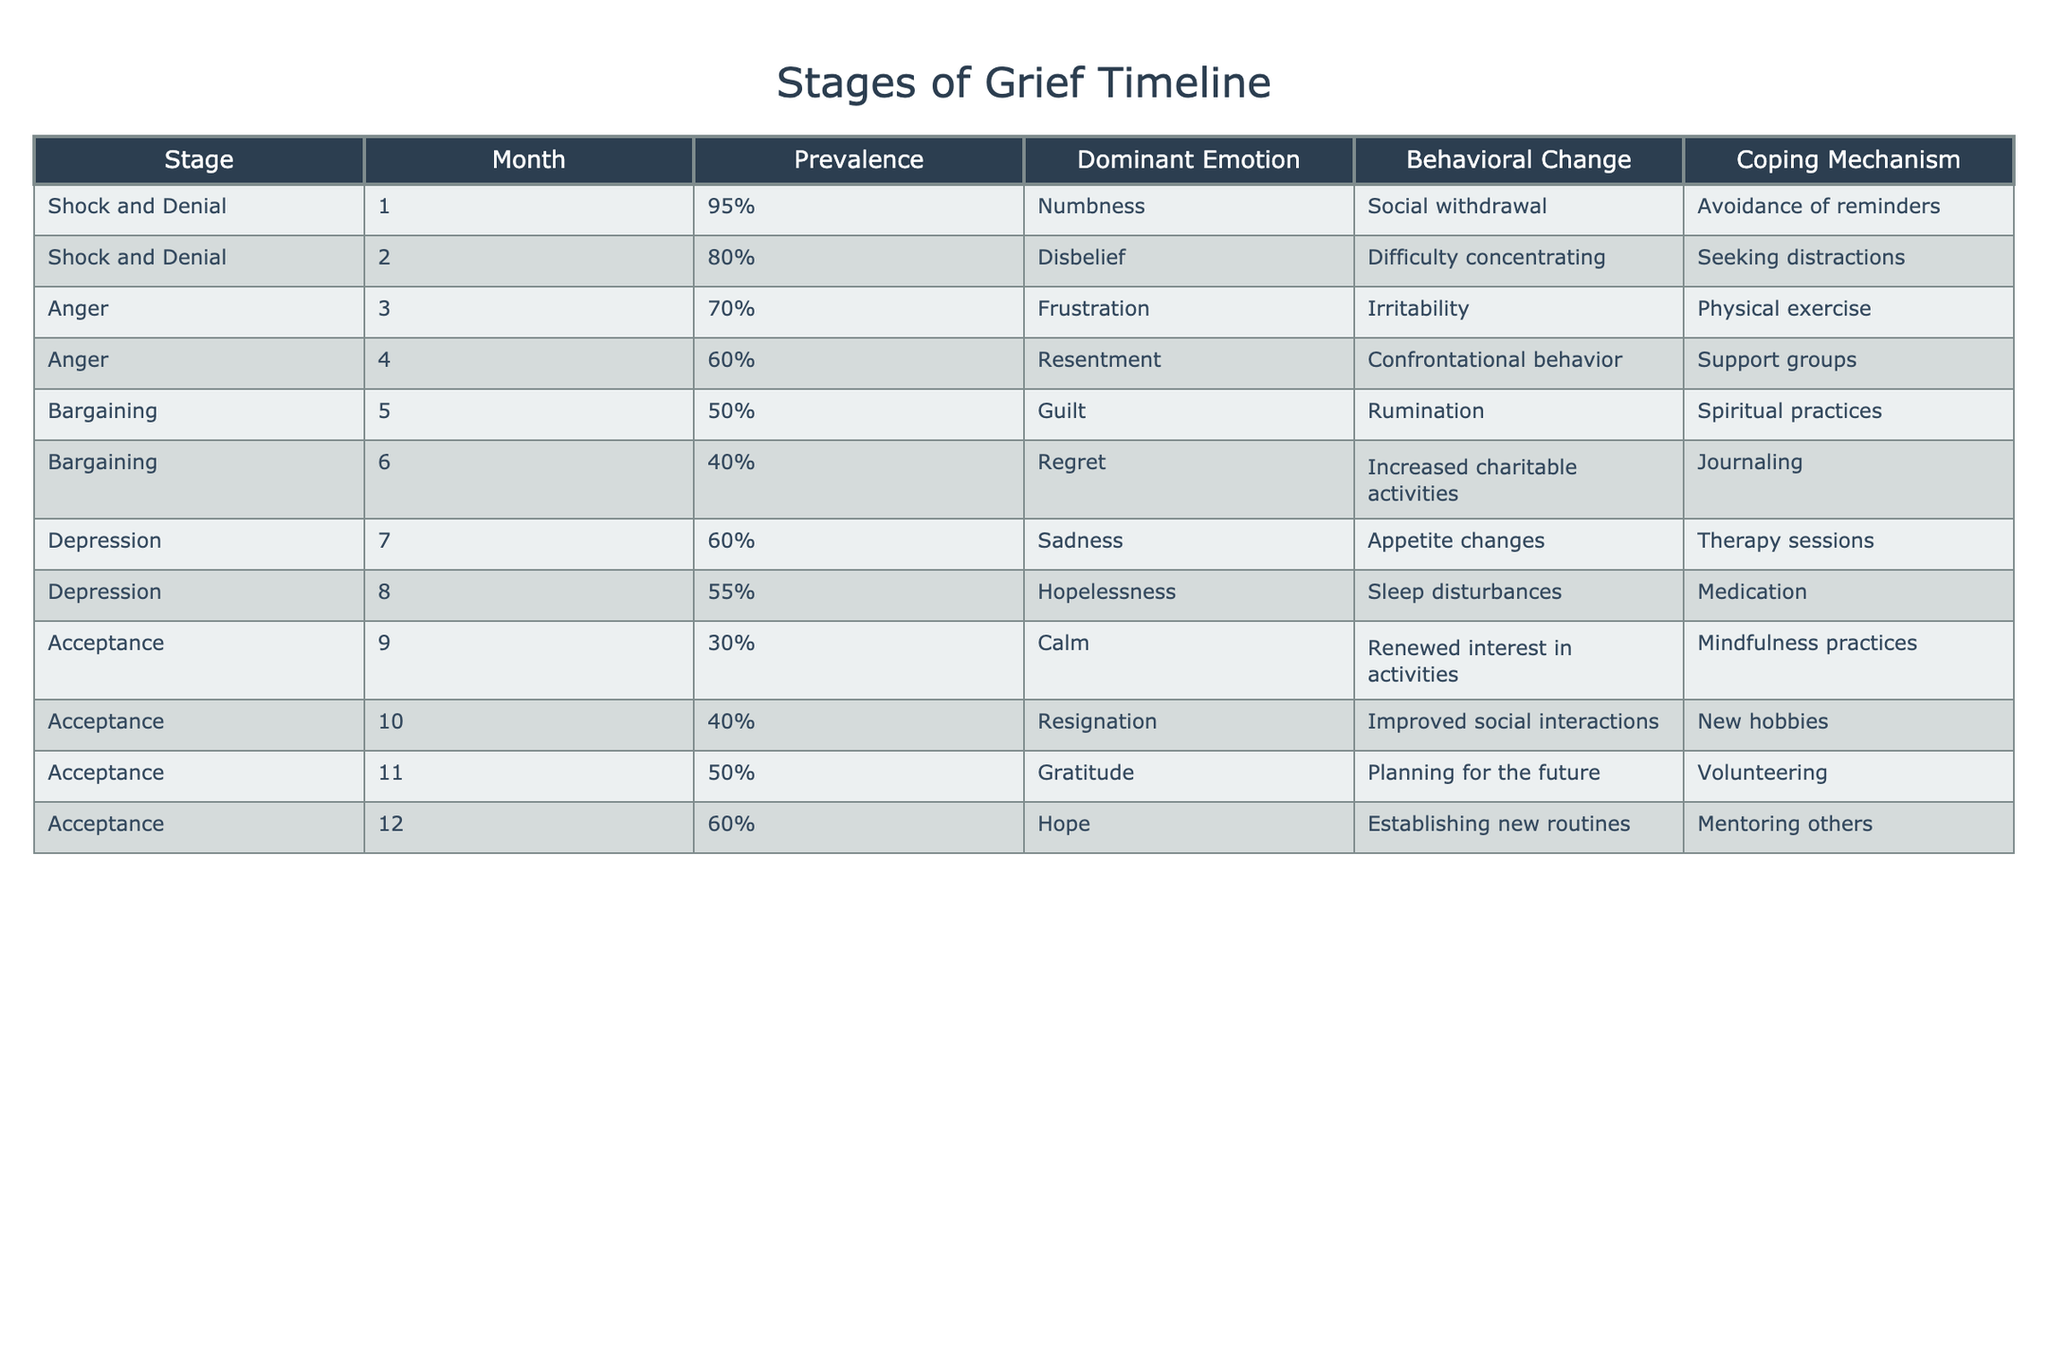What is the dominant emotion at the stage of Depression in the 7th month? From the table, the row corresponding to the 7th month under the Depression stage shows the dominant emotion listed is Sadness.
Answer: Sadness What is the prevalence of the Anger stage in the 4th month? By looking at the table, the prevalence corresponding to the Anger stage in the 4th month is 60%.
Answer: 60% Is the prevalence of the Acceptance stage ever higher than 50%? Yes, referring to the Acceptance stage, its prevalence exceeds 50% in the 11th month where it is 50% and in the 12th month where it is 60%.
Answer: Yes What is the average prevalence during the Bargaining stage? The prevalence values during the Bargaining stage are 50% (5th month) and 40% (6th month). To find the average, we add these values (50 + 40 = 90) and divide by 2, resulting in an average of 45%.
Answer: 45% In which month does the emotion of Resentment peak? The table indicates that the peak of the emotion Resentment occurs in the 4th month, as it is associated with the Anger stage.
Answer: 4th month What percentage decrease in prevalence occurs between the Shock and Denial stage in the 1st month and the Anger stage in the 3rd month? The prevalence during the Shock and Denial stage in the 1st month is 95% and for the Anger stage in the 3rd month it is 70%. The decrease is calculated as (95% - 70%) = 25%.
Answer: 25% Does the coping mechanism of "Avoidance of reminders" appear more than once in the table? No, examining the table reveals that "Avoidance of reminders" is associated only with the Shock and Denial stage in the 1st month.
Answer: No What is the change in dominant emotion from the Depression stage in the 7th month to the 8th month? For the Depression stage, in the 7th month the dominant emotion is Sadness, which changes to Hopelessness in the 8th month. The comparison reveals a transition from Sadness to a deeper sense of Hopelessness.
Answer: From Sadness to Hopelessness 